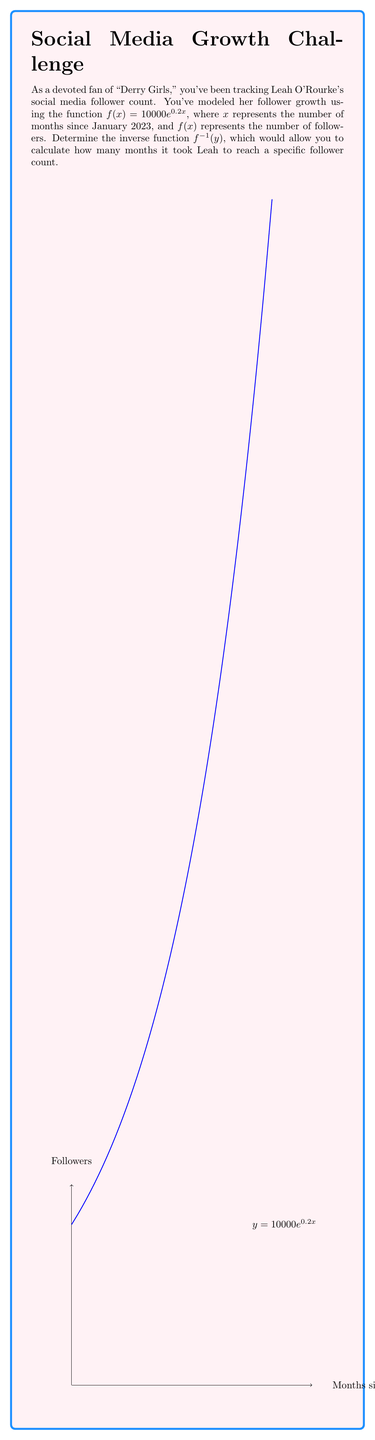Can you answer this question? To find the inverse function, we'll follow these steps:

1) Start with the original function:
   $y = 10000e^{0.2x}$

2) Swap $x$ and $y$:
   $x = 10000e^{0.2y}$

3) Isolate $e^{0.2y}$:
   $\frac{x}{10000} = e^{0.2y}$

4) Take the natural logarithm of both sides:
   $\ln(\frac{x}{10000}) = \ln(e^{0.2y})$

5) Simplify the right side using the property of logarithms:
   $\ln(\frac{x}{10000}) = 0.2y$

6) Isolate $y$:
   $\frac{\ln(\frac{x}{10000})}{0.2} = y$

7) This is our inverse function. Replace $y$ with $f^{-1}(x)$ for standard notation:
   $f^{-1}(x) = \frac{\ln(\frac{x}{10000})}{0.2}$

The domain of this inverse function is $(10000, \infty)$, as Leah's follower count started at 10,000 and can only increase from there.
Answer: $f^{-1}(x) = \frac{\ln(\frac{x}{10000})}{0.2}$ 